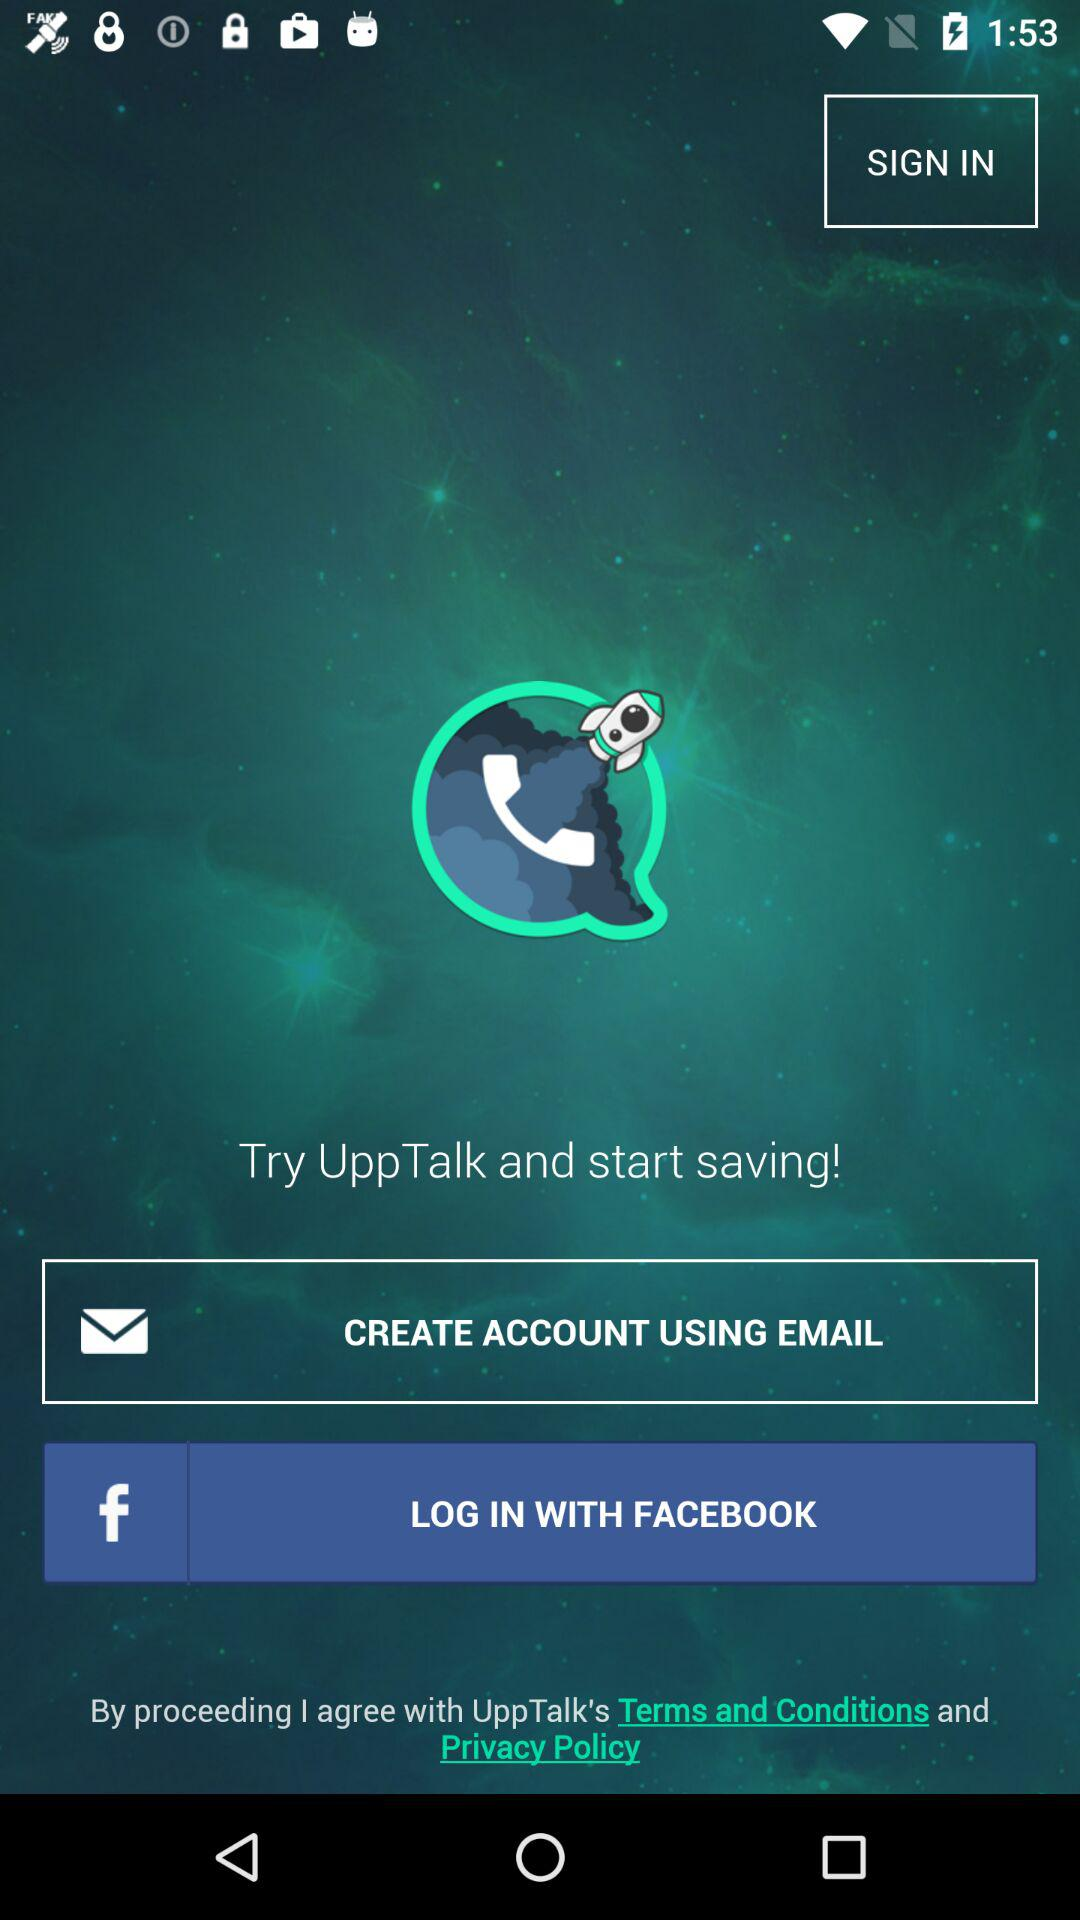What accounts can be used to continue logging in? The account that can be used to log in is Facebook. 